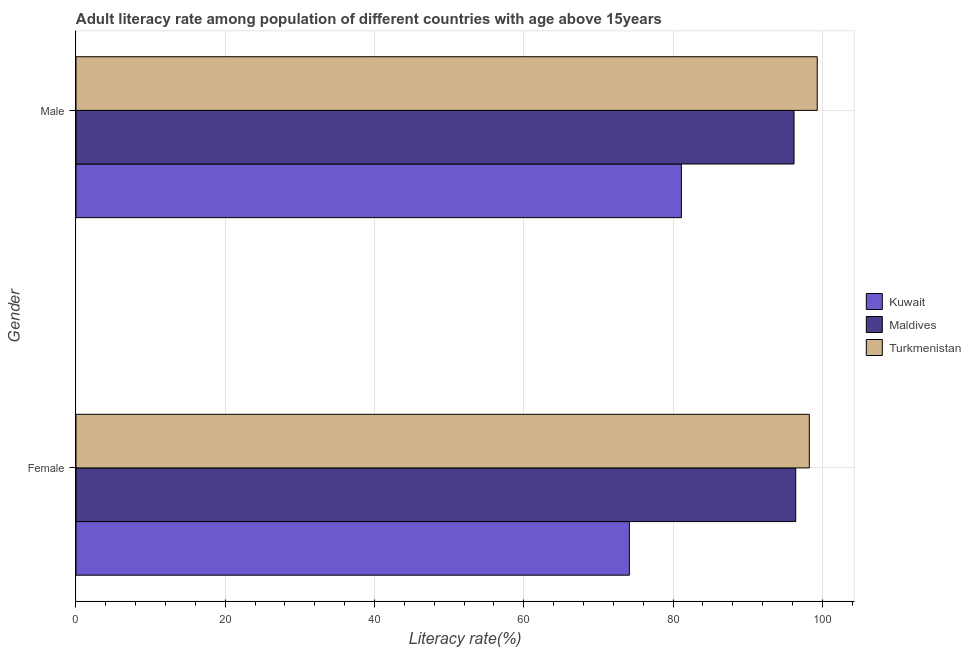How many different coloured bars are there?
Give a very brief answer. 3. Are the number of bars per tick equal to the number of legend labels?
Make the answer very short. Yes. How many bars are there on the 1st tick from the bottom?
Your answer should be very brief. 3. What is the label of the 1st group of bars from the top?
Provide a succinct answer. Male. What is the female adult literacy rate in Kuwait?
Provide a short and direct response. 74.15. Across all countries, what is the maximum female adult literacy rate?
Your answer should be compact. 98.26. Across all countries, what is the minimum female adult literacy rate?
Your answer should be very brief. 74.15. In which country was the female adult literacy rate maximum?
Your answer should be very brief. Turkmenistan. In which country was the male adult literacy rate minimum?
Give a very brief answer. Kuwait. What is the total male adult literacy rate in the graph?
Ensure brevity in your answer.  276.66. What is the difference between the male adult literacy rate in Turkmenistan and that in Maldives?
Provide a succinct answer. 3.11. What is the difference between the male adult literacy rate in Maldives and the female adult literacy rate in Kuwait?
Provide a short and direct response. 22.06. What is the average male adult literacy rate per country?
Offer a very short reply. 92.22. What is the difference between the male adult literacy rate and female adult literacy rate in Turkmenistan?
Provide a short and direct response. 1.06. What is the ratio of the male adult literacy rate in Kuwait to that in Maldives?
Provide a succinct answer. 0.84. In how many countries, is the male adult literacy rate greater than the average male adult literacy rate taken over all countries?
Give a very brief answer. 2. What does the 2nd bar from the top in Male represents?
Your response must be concise. Maldives. What does the 1st bar from the bottom in Female represents?
Provide a succinct answer. Kuwait. Are all the bars in the graph horizontal?
Your answer should be very brief. Yes. How many countries are there in the graph?
Your answer should be very brief. 3. Does the graph contain any zero values?
Your response must be concise. No. Where does the legend appear in the graph?
Your response must be concise. Center right. How are the legend labels stacked?
Ensure brevity in your answer.  Vertical. What is the title of the graph?
Your answer should be compact. Adult literacy rate among population of different countries with age above 15years. Does "European Union" appear as one of the legend labels in the graph?
Your response must be concise. No. What is the label or title of the X-axis?
Offer a very short reply. Literacy rate(%). What is the label or title of the Y-axis?
Provide a short and direct response. Gender. What is the Literacy rate(%) in Kuwait in Female?
Offer a terse response. 74.15. What is the Literacy rate(%) of Maldives in Female?
Give a very brief answer. 96.44. What is the Literacy rate(%) of Turkmenistan in Female?
Give a very brief answer. 98.26. What is the Literacy rate(%) of Kuwait in Male?
Your answer should be compact. 81.12. What is the Literacy rate(%) of Maldives in Male?
Your response must be concise. 96.21. What is the Literacy rate(%) of Turkmenistan in Male?
Make the answer very short. 99.32. Across all Gender, what is the maximum Literacy rate(%) in Kuwait?
Ensure brevity in your answer.  81.12. Across all Gender, what is the maximum Literacy rate(%) in Maldives?
Ensure brevity in your answer.  96.44. Across all Gender, what is the maximum Literacy rate(%) in Turkmenistan?
Ensure brevity in your answer.  99.32. Across all Gender, what is the minimum Literacy rate(%) in Kuwait?
Ensure brevity in your answer.  74.15. Across all Gender, what is the minimum Literacy rate(%) of Maldives?
Ensure brevity in your answer.  96.21. Across all Gender, what is the minimum Literacy rate(%) of Turkmenistan?
Your answer should be compact. 98.26. What is the total Literacy rate(%) in Kuwait in the graph?
Provide a short and direct response. 155.27. What is the total Literacy rate(%) of Maldives in the graph?
Your response must be concise. 192.66. What is the total Literacy rate(%) of Turkmenistan in the graph?
Offer a very short reply. 197.59. What is the difference between the Literacy rate(%) of Kuwait in Female and that in Male?
Give a very brief answer. -6.97. What is the difference between the Literacy rate(%) in Maldives in Female and that in Male?
Keep it short and to the point. 0.23. What is the difference between the Literacy rate(%) of Turkmenistan in Female and that in Male?
Give a very brief answer. -1.06. What is the difference between the Literacy rate(%) of Kuwait in Female and the Literacy rate(%) of Maldives in Male?
Make the answer very short. -22.06. What is the difference between the Literacy rate(%) in Kuwait in Female and the Literacy rate(%) in Turkmenistan in Male?
Your response must be concise. -25.18. What is the difference between the Literacy rate(%) in Maldives in Female and the Literacy rate(%) in Turkmenistan in Male?
Provide a succinct answer. -2.88. What is the average Literacy rate(%) in Kuwait per Gender?
Ensure brevity in your answer.  77.63. What is the average Literacy rate(%) in Maldives per Gender?
Give a very brief answer. 96.33. What is the average Literacy rate(%) in Turkmenistan per Gender?
Make the answer very short. 98.79. What is the difference between the Literacy rate(%) of Kuwait and Literacy rate(%) of Maldives in Female?
Offer a very short reply. -22.29. What is the difference between the Literacy rate(%) in Kuwait and Literacy rate(%) in Turkmenistan in Female?
Your response must be concise. -24.11. What is the difference between the Literacy rate(%) of Maldives and Literacy rate(%) of Turkmenistan in Female?
Offer a terse response. -1.82. What is the difference between the Literacy rate(%) of Kuwait and Literacy rate(%) of Maldives in Male?
Offer a very short reply. -15.09. What is the difference between the Literacy rate(%) of Kuwait and Literacy rate(%) of Turkmenistan in Male?
Make the answer very short. -18.2. What is the difference between the Literacy rate(%) in Maldives and Literacy rate(%) in Turkmenistan in Male?
Give a very brief answer. -3.11. What is the ratio of the Literacy rate(%) of Kuwait in Female to that in Male?
Your answer should be very brief. 0.91. What is the ratio of the Literacy rate(%) of Turkmenistan in Female to that in Male?
Provide a short and direct response. 0.99. What is the difference between the highest and the second highest Literacy rate(%) of Kuwait?
Provide a short and direct response. 6.97. What is the difference between the highest and the second highest Literacy rate(%) in Maldives?
Your response must be concise. 0.23. What is the difference between the highest and the second highest Literacy rate(%) of Turkmenistan?
Your answer should be very brief. 1.06. What is the difference between the highest and the lowest Literacy rate(%) in Kuwait?
Provide a succinct answer. 6.97. What is the difference between the highest and the lowest Literacy rate(%) in Maldives?
Your answer should be compact. 0.23. What is the difference between the highest and the lowest Literacy rate(%) in Turkmenistan?
Offer a very short reply. 1.06. 